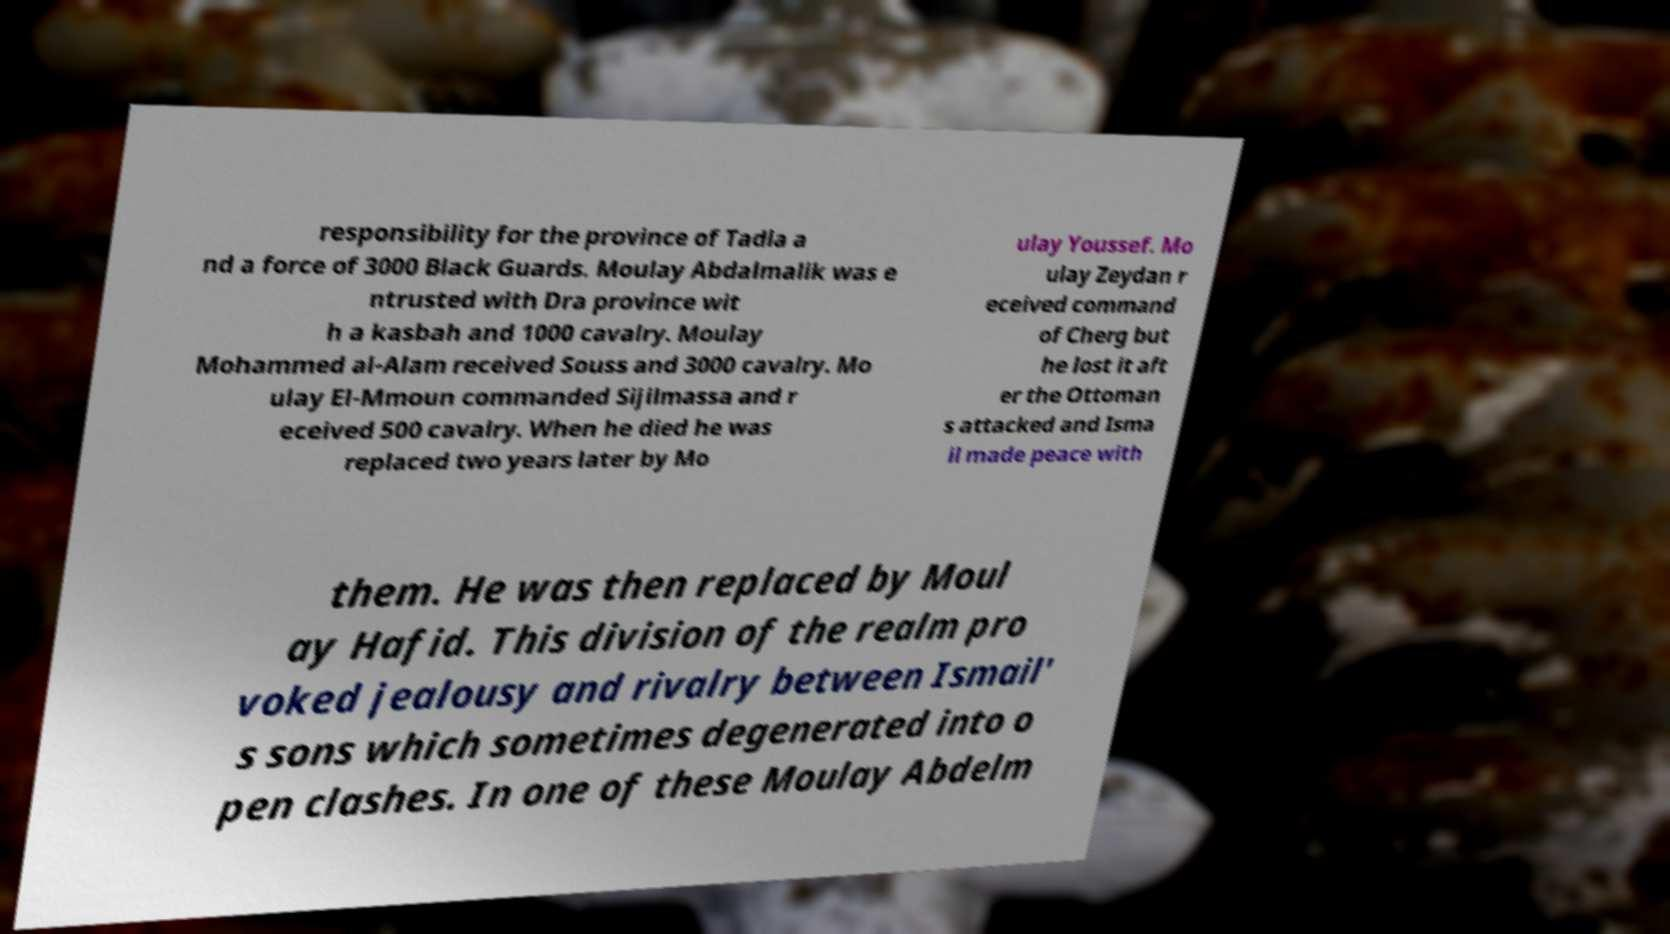Could you extract and type out the text from this image? responsibility for the province of Tadla a nd a force of 3000 Black Guards. Moulay Abdalmalik was e ntrusted with Dra province wit h a kasbah and 1000 cavalry. Moulay Mohammed al-Alam received Souss and 3000 cavalry. Mo ulay El-Mmoun commanded Sijilmassa and r eceived 500 cavalry. When he died he was replaced two years later by Mo ulay Youssef. Mo ulay Zeydan r eceived command of Cherg but he lost it aft er the Ottoman s attacked and Isma il made peace with them. He was then replaced by Moul ay Hafid. This division of the realm pro voked jealousy and rivalry between Ismail' s sons which sometimes degenerated into o pen clashes. In one of these Moulay Abdelm 